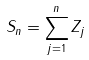Convert formula to latex. <formula><loc_0><loc_0><loc_500><loc_500>S _ { n } = \sum _ { j = 1 } ^ { n } Z _ { j }</formula> 